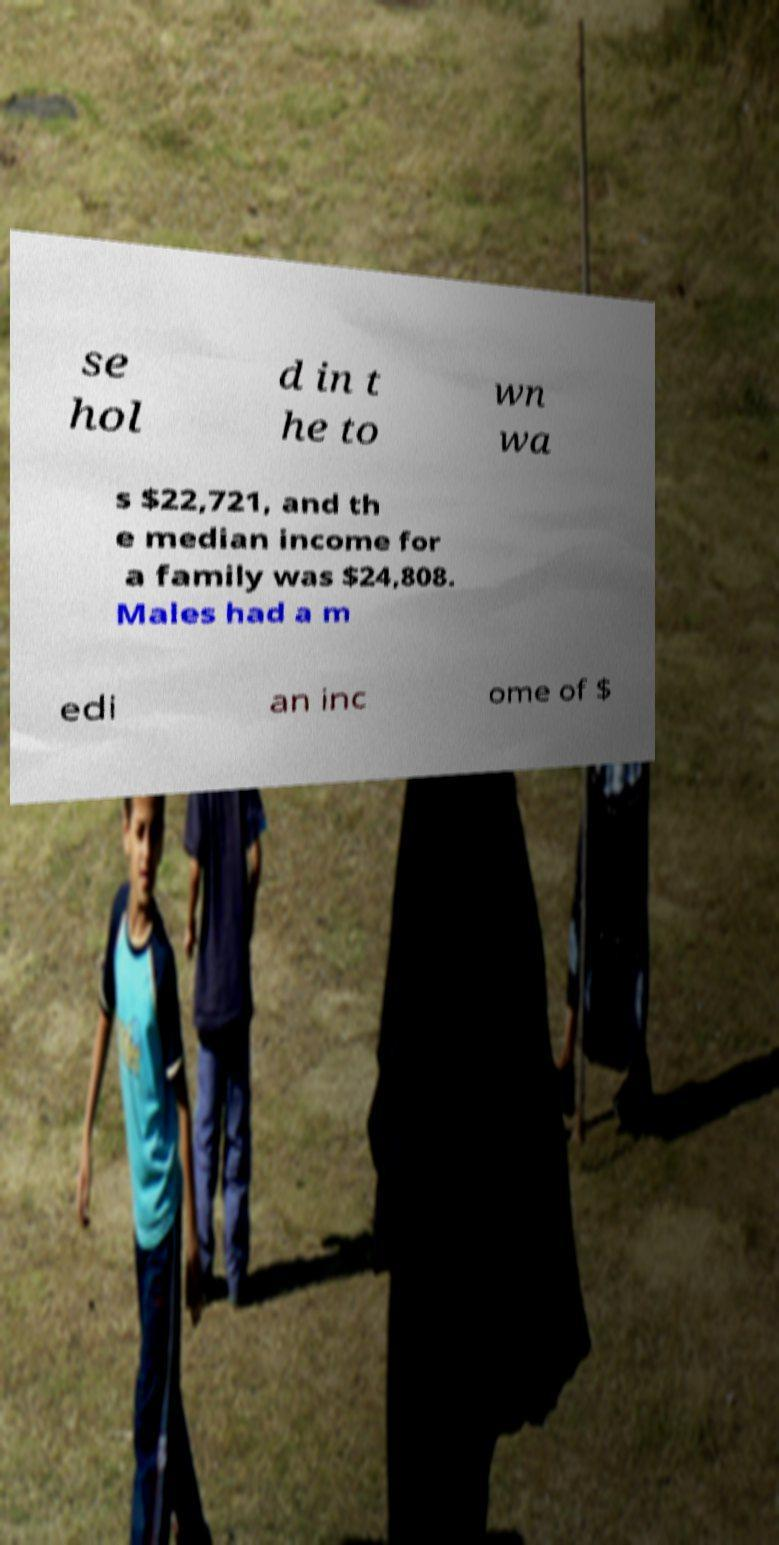There's text embedded in this image that I need extracted. Can you transcribe it verbatim? se hol d in t he to wn wa s $22,721, and th e median income for a family was $24,808. Males had a m edi an inc ome of $ 